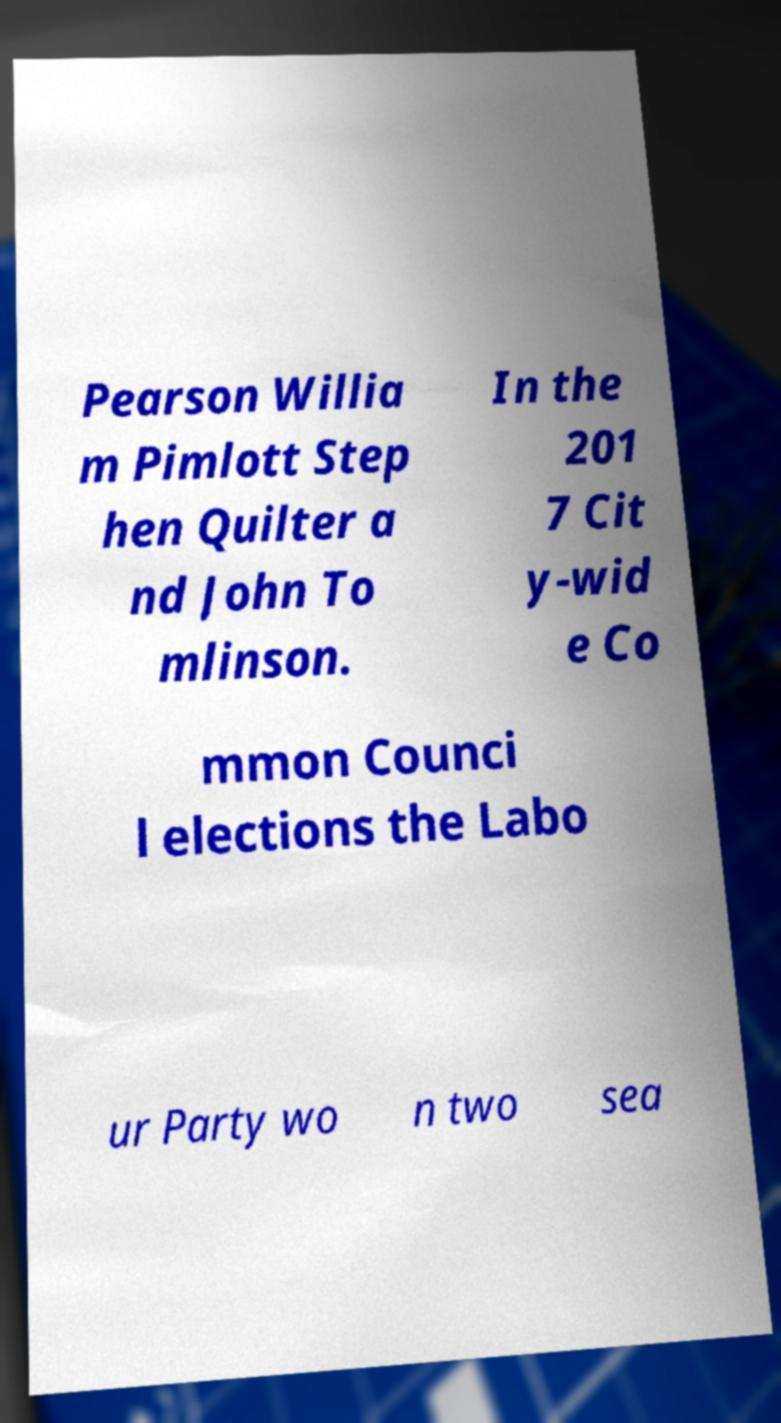I need the written content from this picture converted into text. Can you do that? Pearson Willia m Pimlott Step hen Quilter a nd John To mlinson. In the 201 7 Cit y-wid e Co mmon Counci l elections the Labo ur Party wo n two sea 